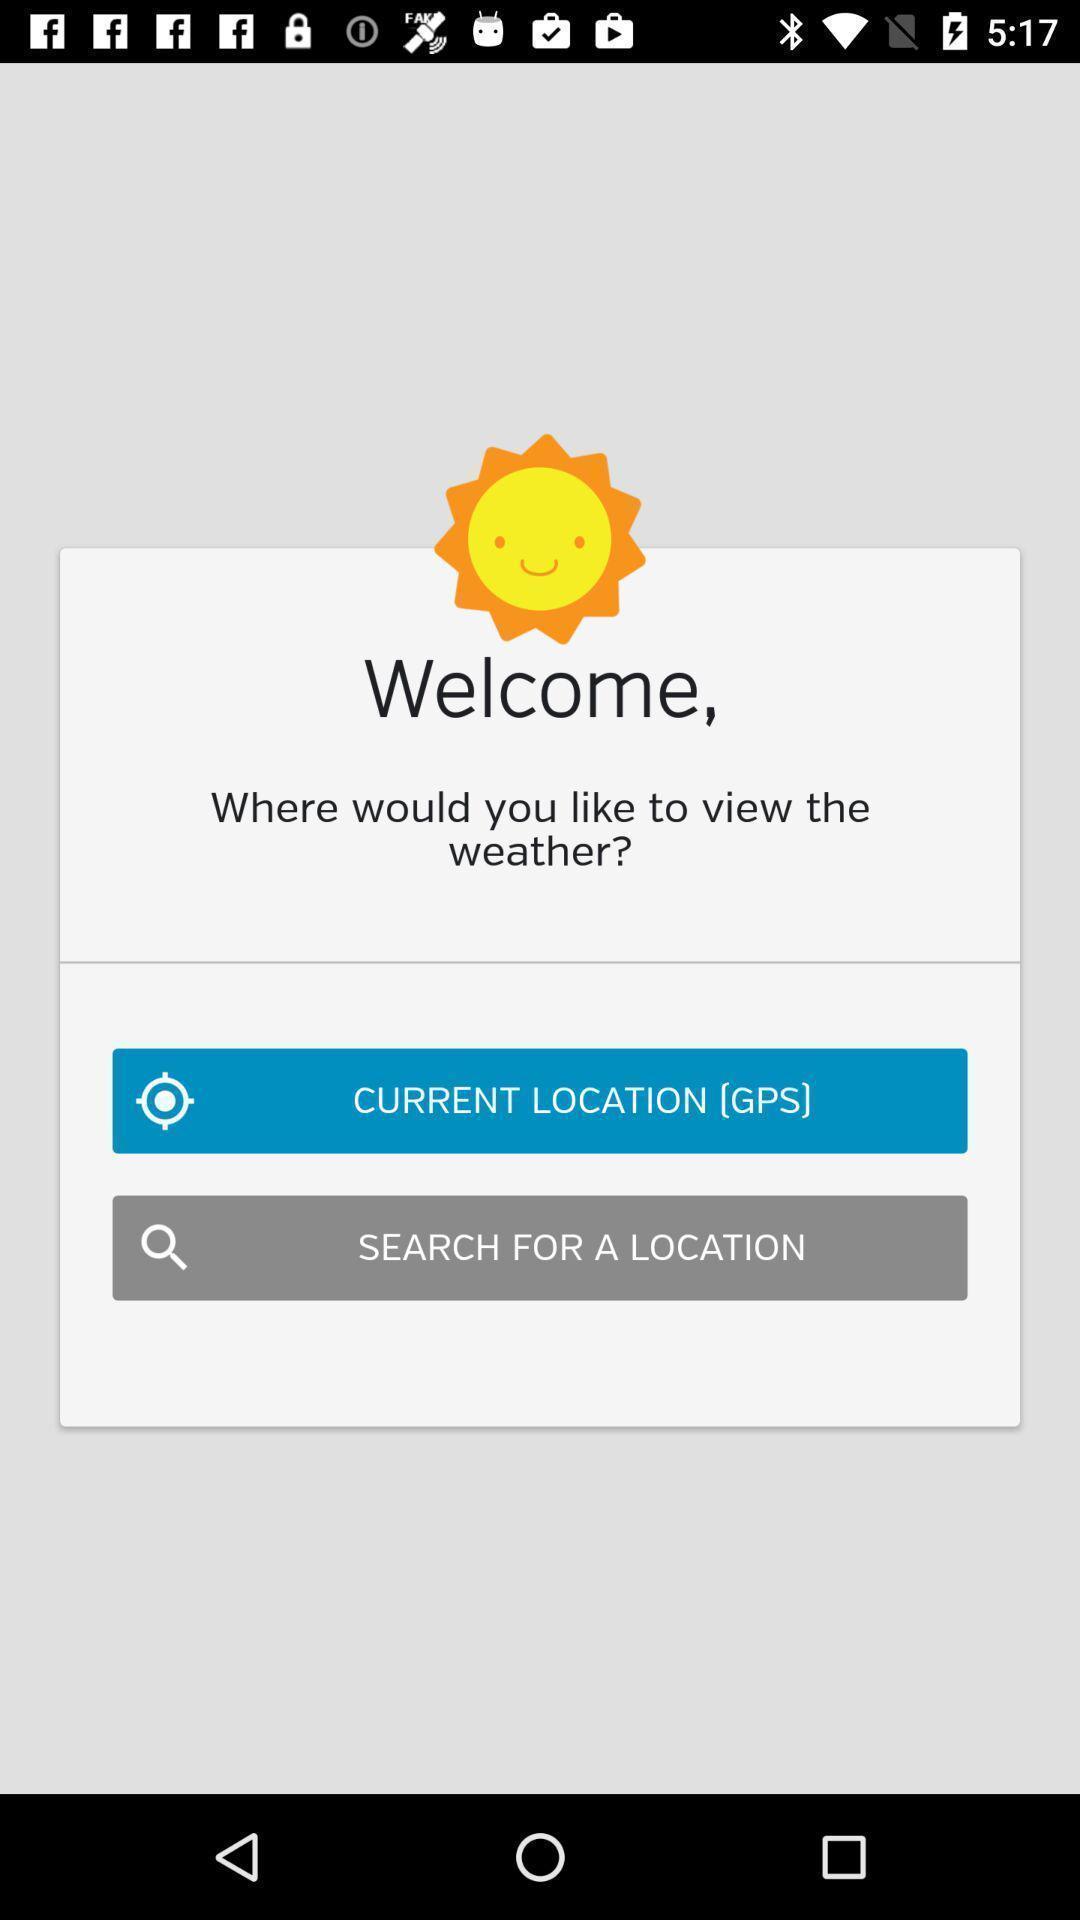Summarize the information in this screenshot. Welcome page of a social app. 